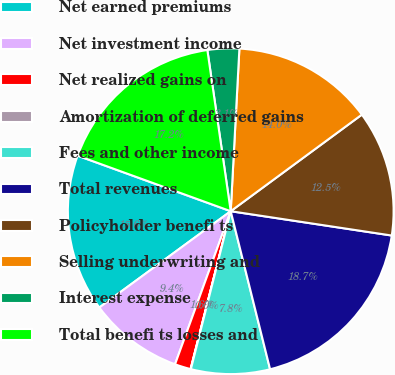Convert chart to OTSL. <chart><loc_0><loc_0><loc_500><loc_500><pie_chart><fcel>Net earned premiums<fcel>Net investment income<fcel>Net realized gains on<fcel>Amortization of deferred gains<fcel>Fees and other income<fcel>Total revenues<fcel>Policyholder benefi ts<fcel>Selling underwriting and<fcel>Interest expense<fcel>Total benefi ts losses and<nl><fcel>15.61%<fcel>9.38%<fcel>1.59%<fcel>0.03%<fcel>7.82%<fcel>18.73%<fcel>12.49%<fcel>14.05%<fcel>3.14%<fcel>17.17%<nl></chart> 